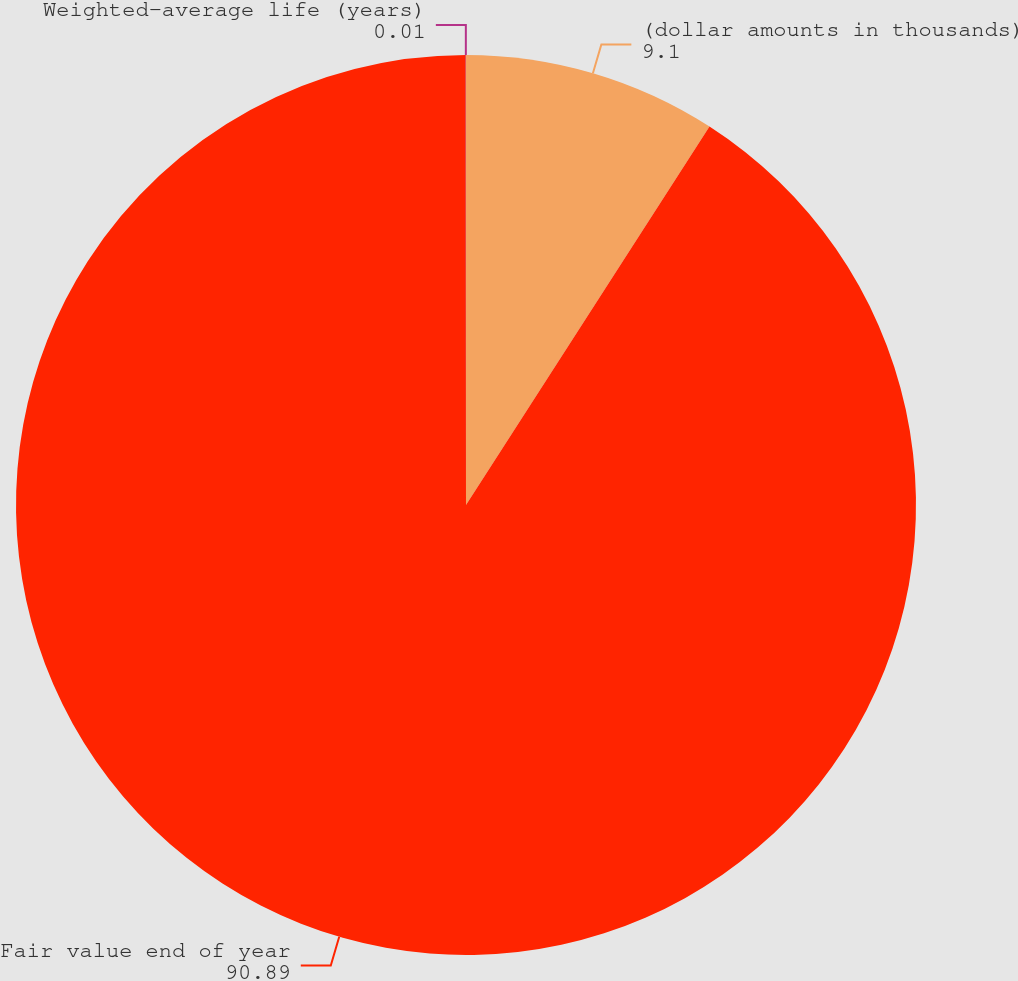<chart> <loc_0><loc_0><loc_500><loc_500><pie_chart><fcel>(dollar amounts in thousands)<fcel>Fair value end of year<fcel>Weighted-average life (years)<nl><fcel>9.1%<fcel>90.89%<fcel>0.01%<nl></chart> 